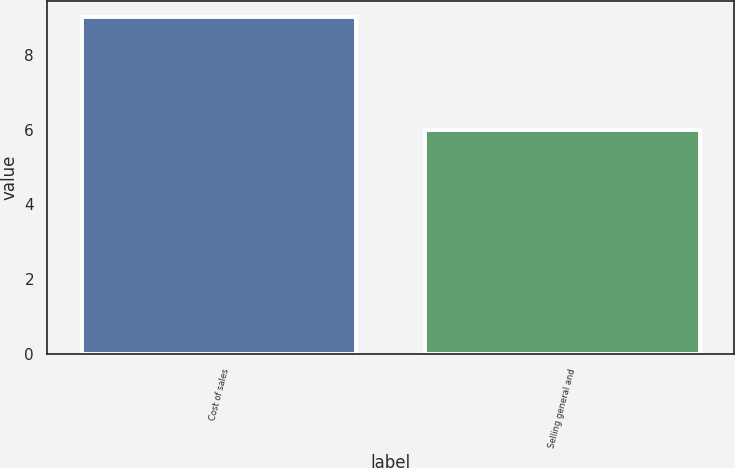Convert chart to OTSL. <chart><loc_0><loc_0><loc_500><loc_500><bar_chart><fcel>Cost of sales<fcel>Selling general and<nl><fcel>9<fcel>6<nl></chart> 